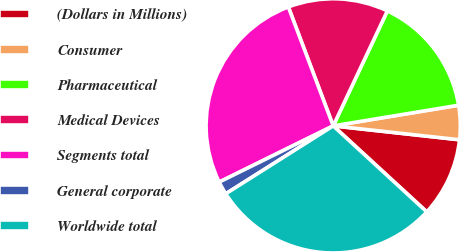Convert chart. <chart><loc_0><loc_0><loc_500><loc_500><pie_chart><fcel>(Dollars in Millions)<fcel>Consumer<fcel>Pharmaceutical<fcel>Medical Devices<fcel>Segments total<fcel>General corporate<fcel>Worldwide total<nl><fcel>10.09%<fcel>4.34%<fcel>15.4%<fcel>12.75%<fcel>26.55%<fcel>1.68%<fcel>29.2%<nl></chart> 